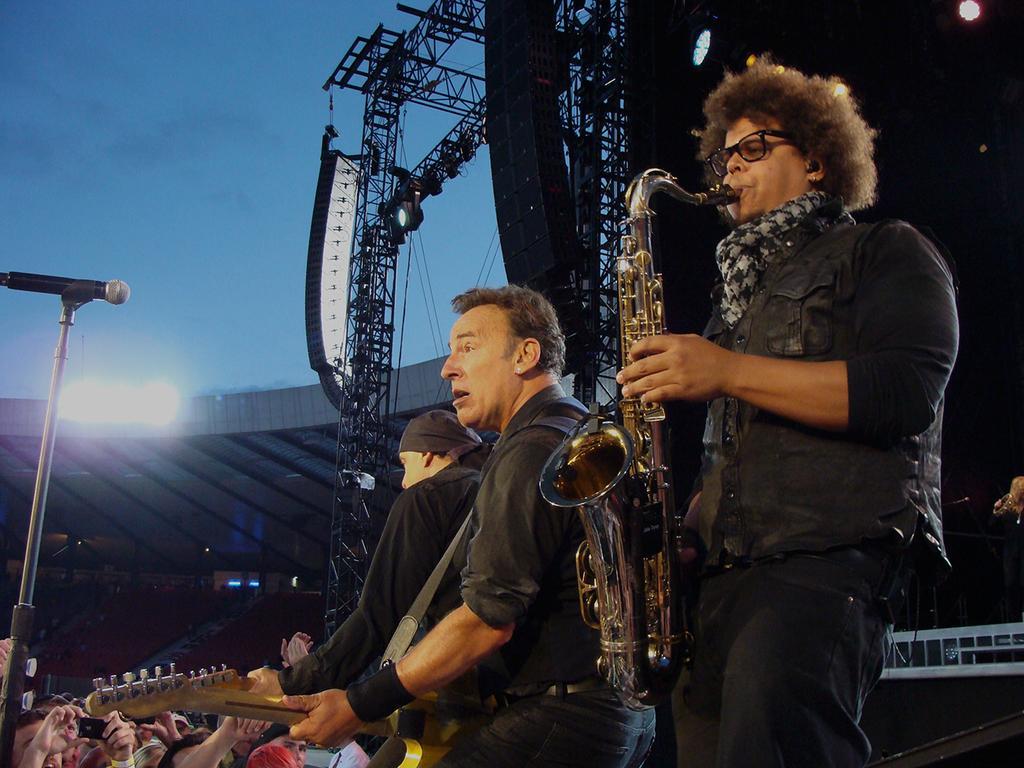Describe this image in one or two sentences. a concert is going on. the person at the right is playing saxophone. the persons left to him are playing guitar. below them people are watching. at the back there is a stage and lights. 